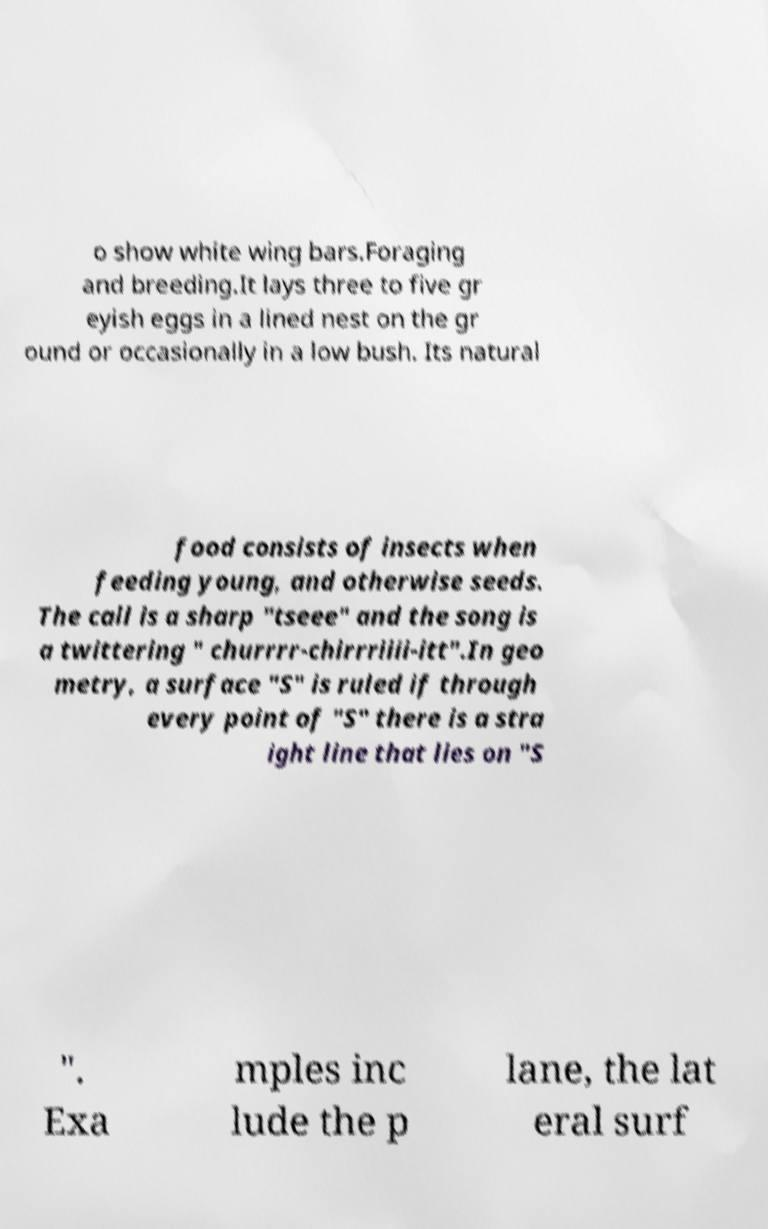Can you accurately transcribe the text from the provided image for me? o show white wing bars.Foraging and breeding.It lays three to five gr eyish eggs in a lined nest on the gr ound or occasionally in a low bush. Its natural food consists of insects when feeding young, and otherwise seeds. The call is a sharp "tseee" and the song is a twittering " churrrr-chirrriiii-itt".In geo metry, a surface "S" is ruled if through every point of "S" there is a stra ight line that lies on "S ". Exa mples inc lude the p lane, the lat eral surf 